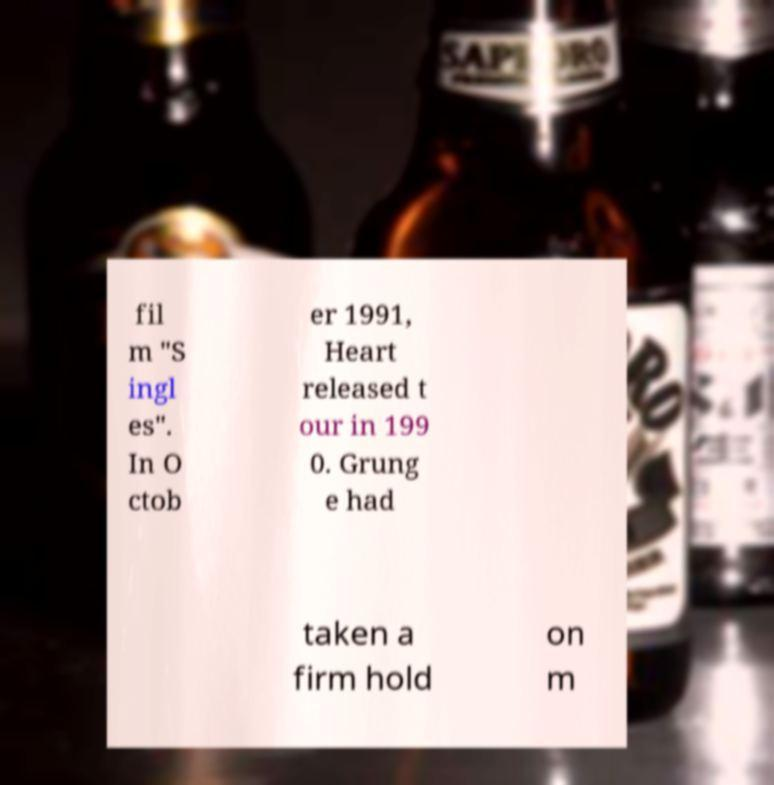Can you accurately transcribe the text from the provided image for me? fil m "S ingl es". In O ctob er 1991, Heart released t our in 199 0. Grung e had taken a firm hold on m 